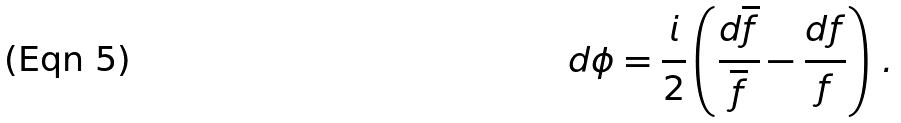<formula> <loc_0><loc_0><loc_500><loc_500>d \phi = \frac { i } { 2 } \left ( \frac { d \overline { f } } { \overline { f } } - \frac { d f } { f } \right ) \, .</formula> 